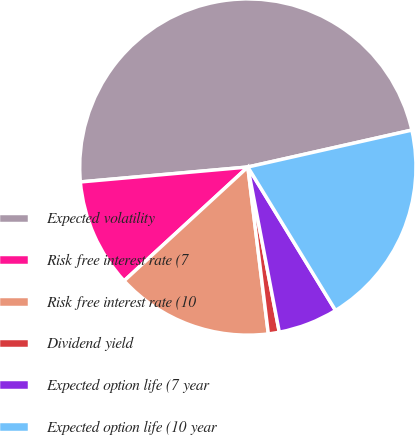<chart> <loc_0><loc_0><loc_500><loc_500><pie_chart><fcel>Expected volatility<fcel>Risk free interest rate (7<fcel>Risk free interest rate (10<fcel>Dividend yield<fcel>Expected option life (7 year<fcel>Expected option life (10 year<nl><fcel>47.89%<fcel>10.42%<fcel>15.11%<fcel>1.05%<fcel>5.74%<fcel>19.79%<nl></chart> 